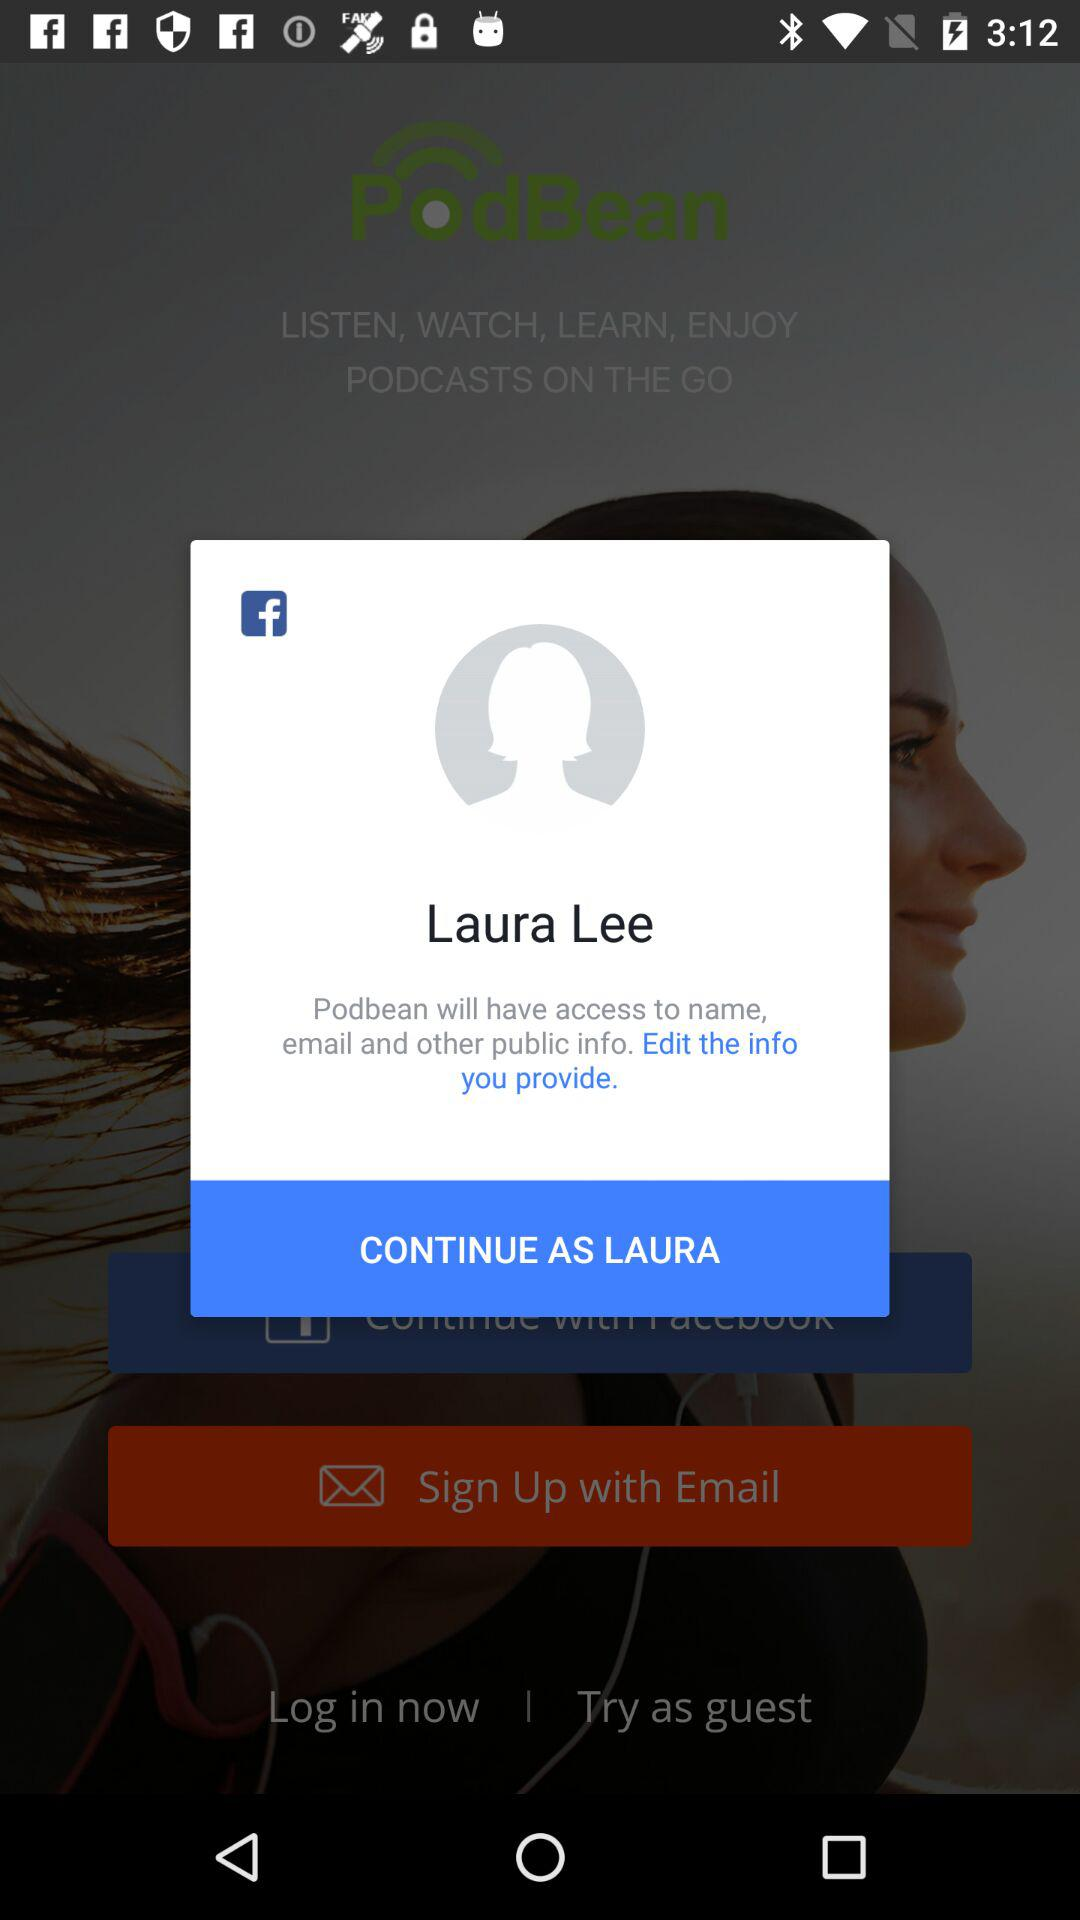Which email address will "Podbean" use?
When the provided information is insufficient, respond with <no answer>. <no answer> 